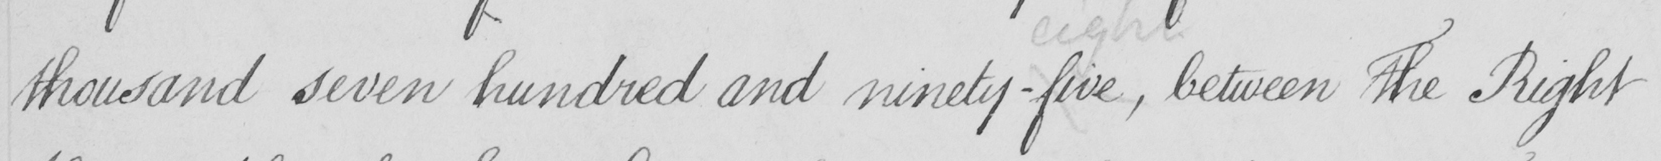Transcribe the text shown in this historical manuscript line. thousand seven hundred and ninety-five , between The Right 